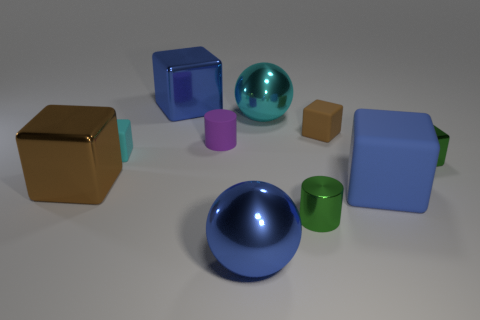How many rubber objects are either blue cylinders or small blocks?
Give a very brief answer. 2. There is a green cylinder that is the same size as the brown matte block; what is its material?
Your answer should be very brief. Metal. What number of other things are made of the same material as the small cyan cube?
Provide a short and direct response. 3. Are there fewer small cyan rubber cubes that are to the left of the small cyan matte object than tiny brown metal cylinders?
Your answer should be very brief. No. Is the small brown thing the same shape as the large brown metallic thing?
Keep it short and to the point. Yes. There is a blue object that is behind the big metallic ball behind the large blue thing that is right of the shiny cylinder; what is its size?
Keep it short and to the point. Large. There is a large blue thing that is the same shape as the large cyan object; what is it made of?
Provide a succinct answer. Metal. There is a blue object that is right of the small shiny object that is in front of the tiny green shiny cube; what is its size?
Your answer should be compact. Large. The tiny shiny block has what color?
Provide a short and direct response. Green. How many brown metal cubes are in front of the blue metallic object that is to the right of the tiny purple rubber cylinder?
Your answer should be very brief. 0. 